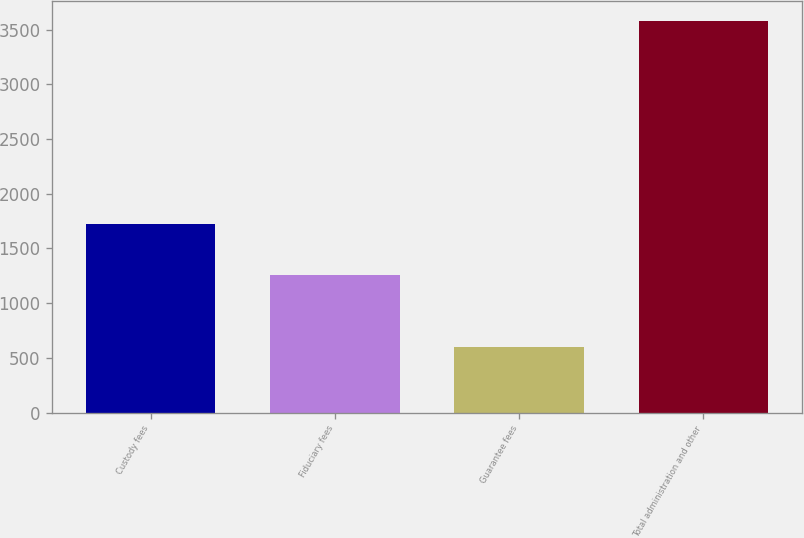Convert chart. <chart><loc_0><loc_0><loc_500><loc_500><bar_chart><fcel>Custody fees<fcel>Fiduciary fees<fcel>Guarantee fees<fcel>Total administration and other<nl><fcel>1728<fcel>1259<fcel>597<fcel>3584<nl></chart> 